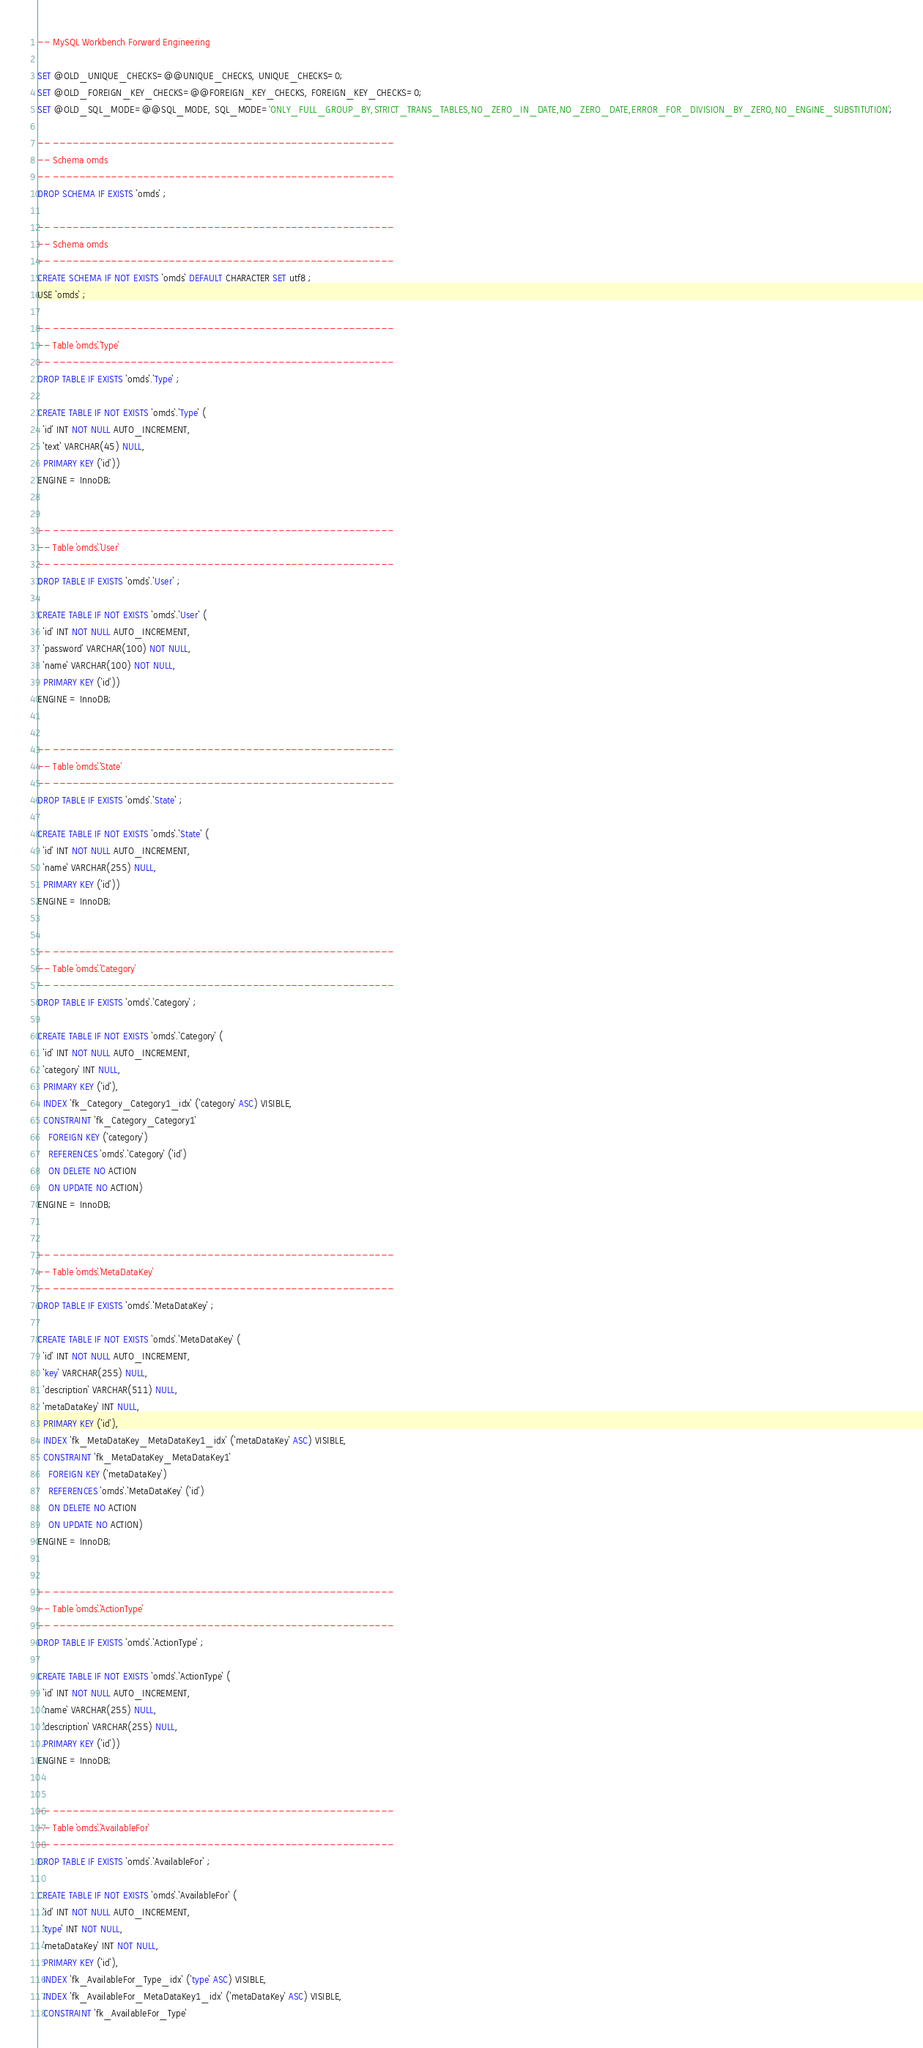<code> <loc_0><loc_0><loc_500><loc_500><_SQL_>-- MySQL Workbench Forward Engineering

SET @OLD_UNIQUE_CHECKS=@@UNIQUE_CHECKS, UNIQUE_CHECKS=0;
SET @OLD_FOREIGN_KEY_CHECKS=@@FOREIGN_KEY_CHECKS, FOREIGN_KEY_CHECKS=0;
SET @OLD_SQL_MODE=@@SQL_MODE, SQL_MODE='ONLY_FULL_GROUP_BY,STRICT_TRANS_TABLES,NO_ZERO_IN_DATE,NO_ZERO_DATE,ERROR_FOR_DIVISION_BY_ZERO,NO_ENGINE_SUBSTITUTION';

-- -----------------------------------------------------
-- Schema omds
-- -----------------------------------------------------
DROP SCHEMA IF EXISTS `omds` ;

-- -----------------------------------------------------
-- Schema omds
-- -----------------------------------------------------
CREATE SCHEMA IF NOT EXISTS `omds` DEFAULT CHARACTER SET utf8 ;
USE `omds` ;

-- -----------------------------------------------------
-- Table `omds`.`Type`
-- -----------------------------------------------------
DROP TABLE IF EXISTS `omds`.`Type` ;

CREATE TABLE IF NOT EXISTS `omds`.`Type` (
  `id` INT NOT NULL AUTO_INCREMENT,
  `text` VARCHAR(45) NULL,
  PRIMARY KEY (`id`))
ENGINE = InnoDB;


-- -----------------------------------------------------
-- Table `omds`.`User`
-- -----------------------------------------------------
DROP TABLE IF EXISTS `omds`.`User` ;

CREATE TABLE IF NOT EXISTS `omds`.`User` (
  `id` INT NOT NULL AUTO_INCREMENT,
  `password` VARCHAR(100) NOT NULL,
  `name` VARCHAR(100) NOT NULL,
  PRIMARY KEY (`id`))
ENGINE = InnoDB;


-- -----------------------------------------------------
-- Table `omds`.`State`
-- -----------------------------------------------------
DROP TABLE IF EXISTS `omds`.`State` ;

CREATE TABLE IF NOT EXISTS `omds`.`State` (
  `id` INT NOT NULL AUTO_INCREMENT,
  `name` VARCHAR(255) NULL,
  PRIMARY KEY (`id`))
ENGINE = InnoDB;


-- -----------------------------------------------------
-- Table `omds`.`Category`
-- -----------------------------------------------------
DROP TABLE IF EXISTS `omds`.`Category` ;

CREATE TABLE IF NOT EXISTS `omds`.`Category` (
  `id` INT NOT NULL AUTO_INCREMENT,
  `category` INT NULL,
  PRIMARY KEY (`id`),
  INDEX `fk_Category_Category1_idx` (`category` ASC) VISIBLE,
  CONSTRAINT `fk_Category_Category1`
    FOREIGN KEY (`category`)
    REFERENCES `omds`.`Category` (`id`)
    ON DELETE NO ACTION
    ON UPDATE NO ACTION)
ENGINE = InnoDB;


-- -----------------------------------------------------
-- Table `omds`.`MetaDataKey`
-- -----------------------------------------------------
DROP TABLE IF EXISTS `omds`.`MetaDataKey` ;

CREATE TABLE IF NOT EXISTS `omds`.`MetaDataKey` (
  `id` INT NOT NULL AUTO_INCREMENT,
  `key` VARCHAR(255) NULL,
  `description` VARCHAR(511) NULL,
  `metaDataKey` INT NULL,
  PRIMARY KEY (`id`),
  INDEX `fk_MetaDataKey_MetaDataKey1_idx` (`metaDataKey` ASC) VISIBLE,
  CONSTRAINT `fk_MetaDataKey_MetaDataKey1`
    FOREIGN KEY (`metaDataKey`)
    REFERENCES `omds`.`MetaDataKey` (`id`)
    ON DELETE NO ACTION
    ON UPDATE NO ACTION)
ENGINE = InnoDB;


-- -----------------------------------------------------
-- Table `omds`.`ActionType`
-- -----------------------------------------------------
DROP TABLE IF EXISTS `omds`.`ActionType` ;

CREATE TABLE IF NOT EXISTS `omds`.`ActionType` (
  `id` INT NOT NULL AUTO_INCREMENT,
  `name` VARCHAR(255) NULL,
  `description` VARCHAR(255) NULL,
  PRIMARY KEY (`id`))
ENGINE = InnoDB;


-- -----------------------------------------------------
-- Table `omds`.`AvailableFor`
-- -----------------------------------------------------
DROP TABLE IF EXISTS `omds`.`AvailableFor` ;

CREATE TABLE IF NOT EXISTS `omds`.`AvailableFor` (
  `id` INT NOT NULL AUTO_INCREMENT,
  `type` INT NOT NULL,
  `metaDataKey` INT NOT NULL,
  PRIMARY KEY (`id`),
  INDEX `fk_AvailableFor_Type_idx` (`type` ASC) VISIBLE,
  INDEX `fk_AvailableFor_MetaDataKey1_idx` (`metaDataKey` ASC) VISIBLE,
  CONSTRAINT `fk_AvailableFor_Type`</code> 